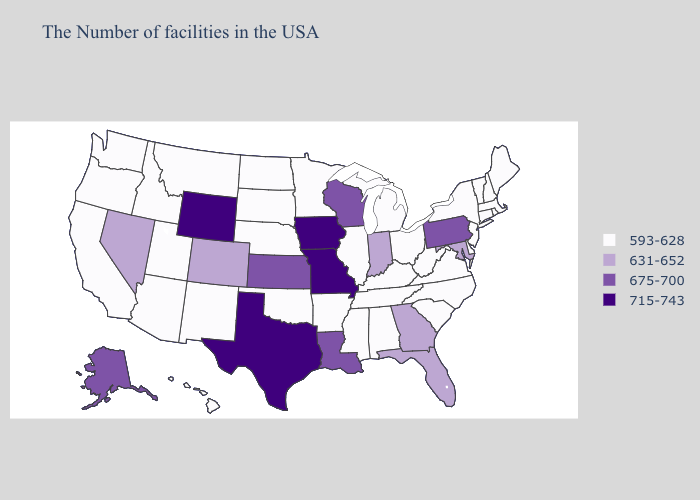What is the value of Tennessee?
Keep it brief. 593-628. Does Tennessee have a higher value than Mississippi?
Be succinct. No. Does Pennsylvania have the lowest value in the Northeast?
Quick response, please. No. Which states have the highest value in the USA?
Quick response, please. Missouri, Iowa, Texas, Wyoming. What is the value of Nevada?
Concise answer only. 631-652. Among the states that border Tennessee , does Kentucky have the highest value?
Quick response, please. No. What is the value of Minnesota?
Quick response, please. 593-628. What is the lowest value in the MidWest?
Short answer required. 593-628. Name the states that have a value in the range 715-743?
Give a very brief answer. Missouri, Iowa, Texas, Wyoming. Name the states that have a value in the range 593-628?
Keep it brief. Maine, Massachusetts, Rhode Island, New Hampshire, Vermont, Connecticut, New York, New Jersey, Delaware, Virginia, North Carolina, South Carolina, West Virginia, Ohio, Michigan, Kentucky, Alabama, Tennessee, Illinois, Mississippi, Arkansas, Minnesota, Nebraska, Oklahoma, South Dakota, North Dakota, New Mexico, Utah, Montana, Arizona, Idaho, California, Washington, Oregon, Hawaii. Name the states that have a value in the range 631-652?
Be succinct. Maryland, Florida, Georgia, Indiana, Colorado, Nevada. What is the highest value in states that border Wyoming?
Short answer required. 631-652. Does Washington have a lower value than Colorado?
Concise answer only. Yes. Name the states that have a value in the range 593-628?
Keep it brief. Maine, Massachusetts, Rhode Island, New Hampshire, Vermont, Connecticut, New York, New Jersey, Delaware, Virginia, North Carolina, South Carolina, West Virginia, Ohio, Michigan, Kentucky, Alabama, Tennessee, Illinois, Mississippi, Arkansas, Minnesota, Nebraska, Oklahoma, South Dakota, North Dakota, New Mexico, Utah, Montana, Arizona, Idaho, California, Washington, Oregon, Hawaii. Which states have the lowest value in the USA?
Short answer required. Maine, Massachusetts, Rhode Island, New Hampshire, Vermont, Connecticut, New York, New Jersey, Delaware, Virginia, North Carolina, South Carolina, West Virginia, Ohio, Michigan, Kentucky, Alabama, Tennessee, Illinois, Mississippi, Arkansas, Minnesota, Nebraska, Oklahoma, South Dakota, North Dakota, New Mexico, Utah, Montana, Arizona, Idaho, California, Washington, Oregon, Hawaii. 